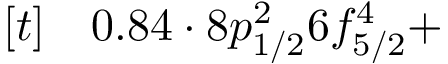<formula> <loc_0><loc_0><loc_500><loc_500>\begin{array} { r l } { [ t ] } & 0 . 8 4 \cdot 8 p _ { 1 / 2 } ^ { 2 } 6 f _ { 5 / 2 } ^ { 4 } + } \end{array}</formula> 